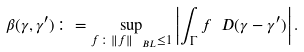<formula> <loc_0><loc_0><loc_500><loc_500>\beta ( \gamma , \gamma ^ { \prime } ) \colon = \sup _ { f \colon \left \| f \right \| _ { \ B L } \leq 1 } \left | \int _ { \Gamma } f \ D ( \gamma - \gamma ^ { \prime } ) \right | .</formula> 